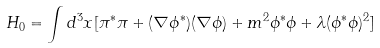Convert formula to latex. <formula><loc_0><loc_0><loc_500><loc_500>H _ { 0 } = \int d ^ { 3 } x [ \pi ^ { * } \pi + ( \nabla \phi ^ { * } ) ( \nabla \phi ) + m ^ { 2 } \phi ^ { * } \phi + \lambda ( \phi ^ { * } \phi ) ^ { 2 } ]</formula> 